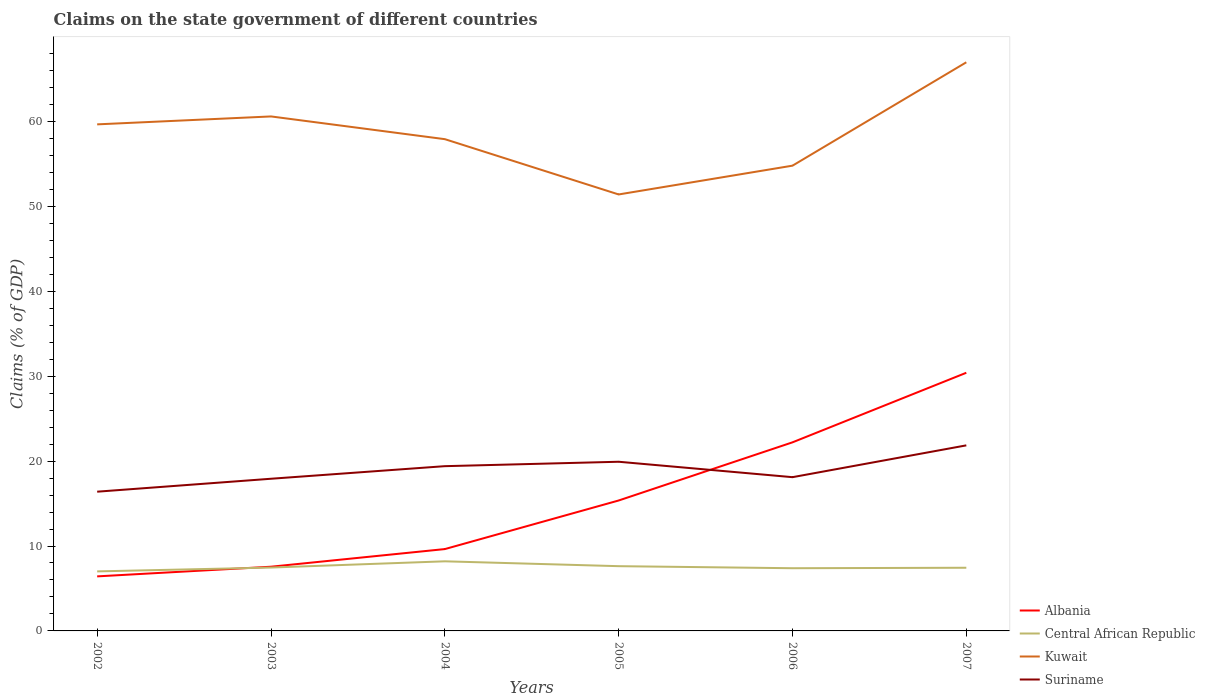Across all years, what is the maximum percentage of GDP claimed on the state government in Kuwait?
Provide a succinct answer. 51.41. In which year was the percentage of GDP claimed on the state government in Suriname maximum?
Your answer should be compact. 2002. What is the total percentage of GDP claimed on the state government in Suriname in the graph?
Keep it short and to the point. -1.93. What is the difference between the highest and the second highest percentage of GDP claimed on the state government in Kuwait?
Your response must be concise. 15.57. Is the percentage of GDP claimed on the state government in Suriname strictly greater than the percentage of GDP claimed on the state government in Central African Republic over the years?
Provide a short and direct response. No. How many years are there in the graph?
Ensure brevity in your answer.  6. What is the difference between two consecutive major ticks on the Y-axis?
Provide a succinct answer. 10. Does the graph contain grids?
Your answer should be very brief. No. Where does the legend appear in the graph?
Keep it short and to the point. Bottom right. What is the title of the graph?
Your answer should be very brief. Claims on the state government of different countries. Does "Bosnia and Herzegovina" appear as one of the legend labels in the graph?
Offer a terse response. No. What is the label or title of the Y-axis?
Your response must be concise. Claims (% of GDP). What is the Claims (% of GDP) in Albania in 2002?
Your response must be concise. 6.42. What is the Claims (% of GDP) of Central African Republic in 2002?
Your answer should be very brief. 7.01. What is the Claims (% of GDP) in Kuwait in 2002?
Your response must be concise. 59.66. What is the Claims (% of GDP) of Suriname in 2002?
Ensure brevity in your answer.  16.4. What is the Claims (% of GDP) in Albania in 2003?
Make the answer very short. 7.56. What is the Claims (% of GDP) in Central African Republic in 2003?
Your response must be concise. 7.46. What is the Claims (% of GDP) of Kuwait in 2003?
Your response must be concise. 60.59. What is the Claims (% of GDP) of Suriname in 2003?
Your answer should be very brief. 17.92. What is the Claims (% of GDP) of Albania in 2004?
Ensure brevity in your answer.  9.64. What is the Claims (% of GDP) in Central African Republic in 2004?
Provide a short and direct response. 8.2. What is the Claims (% of GDP) in Kuwait in 2004?
Ensure brevity in your answer.  57.92. What is the Claims (% of GDP) in Suriname in 2004?
Ensure brevity in your answer.  19.4. What is the Claims (% of GDP) of Albania in 2005?
Your response must be concise. 15.36. What is the Claims (% of GDP) in Central African Republic in 2005?
Your answer should be compact. 7.63. What is the Claims (% of GDP) in Kuwait in 2005?
Keep it short and to the point. 51.41. What is the Claims (% of GDP) in Suriname in 2005?
Your answer should be very brief. 19.92. What is the Claims (% of GDP) in Albania in 2006?
Offer a very short reply. 22.21. What is the Claims (% of GDP) of Central African Republic in 2006?
Offer a terse response. 7.38. What is the Claims (% of GDP) in Kuwait in 2006?
Make the answer very short. 54.8. What is the Claims (% of GDP) in Suriname in 2006?
Make the answer very short. 18.11. What is the Claims (% of GDP) in Albania in 2007?
Offer a very short reply. 30.41. What is the Claims (% of GDP) of Central African Republic in 2007?
Your answer should be compact. 7.44. What is the Claims (% of GDP) in Kuwait in 2007?
Offer a very short reply. 66.97. What is the Claims (% of GDP) in Suriname in 2007?
Offer a terse response. 21.85. Across all years, what is the maximum Claims (% of GDP) in Albania?
Offer a very short reply. 30.41. Across all years, what is the maximum Claims (% of GDP) of Central African Republic?
Offer a terse response. 8.2. Across all years, what is the maximum Claims (% of GDP) in Kuwait?
Keep it short and to the point. 66.97. Across all years, what is the maximum Claims (% of GDP) in Suriname?
Make the answer very short. 21.85. Across all years, what is the minimum Claims (% of GDP) in Albania?
Your answer should be very brief. 6.42. Across all years, what is the minimum Claims (% of GDP) of Central African Republic?
Your response must be concise. 7.01. Across all years, what is the minimum Claims (% of GDP) of Kuwait?
Your answer should be very brief. 51.41. Across all years, what is the minimum Claims (% of GDP) of Suriname?
Your response must be concise. 16.4. What is the total Claims (% of GDP) in Albania in the graph?
Ensure brevity in your answer.  91.6. What is the total Claims (% of GDP) of Central African Republic in the graph?
Your answer should be compact. 45.12. What is the total Claims (% of GDP) in Kuwait in the graph?
Give a very brief answer. 351.34. What is the total Claims (% of GDP) in Suriname in the graph?
Keep it short and to the point. 113.61. What is the difference between the Claims (% of GDP) of Albania in 2002 and that in 2003?
Keep it short and to the point. -1.14. What is the difference between the Claims (% of GDP) of Central African Republic in 2002 and that in 2003?
Keep it short and to the point. -0.45. What is the difference between the Claims (% of GDP) in Kuwait in 2002 and that in 2003?
Give a very brief answer. -0.93. What is the difference between the Claims (% of GDP) in Suriname in 2002 and that in 2003?
Keep it short and to the point. -1.52. What is the difference between the Claims (% of GDP) in Albania in 2002 and that in 2004?
Make the answer very short. -3.21. What is the difference between the Claims (% of GDP) in Central African Republic in 2002 and that in 2004?
Your answer should be very brief. -1.19. What is the difference between the Claims (% of GDP) of Kuwait in 2002 and that in 2004?
Offer a very short reply. 1.74. What is the difference between the Claims (% of GDP) in Suriname in 2002 and that in 2004?
Provide a short and direct response. -3.01. What is the difference between the Claims (% of GDP) of Albania in 2002 and that in 2005?
Your answer should be very brief. -8.94. What is the difference between the Claims (% of GDP) in Central African Republic in 2002 and that in 2005?
Your answer should be compact. -0.62. What is the difference between the Claims (% of GDP) in Kuwait in 2002 and that in 2005?
Offer a terse response. 8.25. What is the difference between the Claims (% of GDP) in Suriname in 2002 and that in 2005?
Your answer should be compact. -3.53. What is the difference between the Claims (% of GDP) in Albania in 2002 and that in 2006?
Give a very brief answer. -15.79. What is the difference between the Claims (% of GDP) in Central African Republic in 2002 and that in 2006?
Offer a terse response. -0.37. What is the difference between the Claims (% of GDP) in Kuwait in 2002 and that in 2006?
Keep it short and to the point. 4.87. What is the difference between the Claims (% of GDP) in Suriname in 2002 and that in 2006?
Make the answer very short. -1.71. What is the difference between the Claims (% of GDP) of Albania in 2002 and that in 2007?
Make the answer very short. -23.98. What is the difference between the Claims (% of GDP) of Central African Republic in 2002 and that in 2007?
Provide a succinct answer. -0.43. What is the difference between the Claims (% of GDP) in Kuwait in 2002 and that in 2007?
Provide a succinct answer. -7.31. What is the difference between the Claims (% of GDP) in Suriname in 2002 and that in 2007?
Your answer should be compact. -5.46. What is the difference between the Claims (% of GDP) in Albania in 2003 and that in 2004?
Your answer should be compact. -2.08. What is the difference between the Claims (% of GDP) of Central African Republic in 2003 and that in 2004?
Provide a short and direct response. -0.73. What is the difference between the Claims (% of GDP) of Kuwait in 2003 and that in 2004?
Keep it short and to the point. 2.68. What is the difference between the Claims (% of GDP) of Suriname in 2003 and that in 2004?
Give a very brief answer. -1.48. What is the difference between the Claims (% of GDP) in Albania in 2003 and that in 2005?
Keep it short and to the point. -7.8. What is the difference between the Claims (% of GDP) in Central African Republic in 2003 and that in 2005?
Offer a terse response. -0.16. What is the difference between the Claims (% of GDP) of Kuwait in 2003 and that in 2005?
Your answer should be very brief. 9.19. What is the difference between the Claims (% of GDP) of Suriname in 2003 and that in 2005?
Offer a very short reply. -2. What is the difference between the Claims (% of GDP) in Albania in 2003 and that in 2006?
Provide a short and direct response. -14.65. What is the difference between the Claims (% of GDP) in Central African Republic in 2003 and that in 2006?
Keep it short and to the point. 0.08. What is the difference between the Claims (% of GDP) in Kuwait in 2003 and that in 2006?
Keep it short and to the point. 5.8. What is the difference between the Claims (% of GDP) of Suriname in 2003 and that in 2006?
Offer a very short reply. -0.19. What is the difference between the Claims (% of GDP) in Albania in 2003 and that in 2007?
Make the answer very short. -22.84. What is the difference between the Claims (% of GDP) of Central African Republic in 2003 and that in 2007?
Ensure brevity in your answer.  0.02. What is the difference between the Claims (% of GDP) in Kuwait in 2003 and that in 2007?
Keep it short and to the point. -6.38. What is the difference between the Claims (% of GDP) of Suriname in 2003 and that in 2007?
Offer a very short reply. -3.93. What is the difference between the Claims (% of GDP) in Albania in 2004 and that in 2005?
Ensure brevity in your answer.  -5.72. What is the difference between the Claims (% of GDP) of Central African Republic in 2004 and that in 2005?
Provide a succinct answer. 0.57. What is the difference between the Claims (% of GDP) in Kuwait in 2004 and that in 2005?
Your answer should be very brief. 6.51. What is the difference between the Claims (% of GDP) in Suriname in 2004 and that in 2005?
Your answer should be compact. -0.52. What is the difference between the Claims (% of GDP) of Albania in 2004 and that in 2006?
Ensure brevity in your answer.  -12.57. What is the difference between the Claims (% of GDP) of Central African Republic in 2004 and that in 2006?
Offer a terse response. 0.81. What is the difference between the Claims (% of GDP) in Kuwait in 2004 and that in 2006?
Your response must be concise. 3.12. What is the difference between the Claims (% of GDP) of Suriname in 2004 and that in 2006?
Offer a terse response. 1.3. What is the difference between the Claims (% of GDP) in Albania in 2004 and that in 2007?
Offer a very short reply. -20.77. What is the difference between the Claims (% of GDP) in Central African Republic in 2004 and that in 2007?
Your response must be concise. 0.76. What is the difference between the Claims (% of GDP) in Kuwait in 2004 and that in 2007?
Give a very brief answer. -9.05. What is the difference between the Claims (% of GDP) in Suriname in 2004 and that in 2007?
Keep it short and to the point. -2.45. What is the difference between the Claims (% of GDP) in Albania in 2005 and that in 2006?
Offer a very short reply. -6.85. What is the difference between the Claims (% of GDP) in Central African Republic in 2005 and that in 2006?
Your response must be concise. 0.24. What is the difference between the Claims (% of GDP) in Kuwait in 2005 and that in 2006?
Give a very brief answer. -3.39. What is the difference between the Claims (% of GDP) of Suriname in 2005 and that in 2006?
Ensure brevity in your answer.  1.82. What is the difference between the Claims (% of GDP) in Albania in 2005 and that in 2007?
Make the answer very short. -15.04. What is the difference between the Claims (% of GDP) of Central African Republic in 2005 and that in 2007?
Your response must be concise. 0.19. What is the difference between the Claims (% of GDP) in Kuwait in 2005 and that in 2007?
Provide a succinct answer. -15.57. What is the difference between the Claims (% of GDP) of Suriname in 2005 and that in 2007?
Make the answer very short. -1.93. What is the difference between the Claims (% of GDP) in Albania in 2006 and that in 2007?
Provide a succinct answer. -8.19. What is the difference between the Claims (% of GDP) in Central African Republic in 2006 and that in 2007?
Your answer should be compact. -0.06. What is the difference between the Claims (% of GDP) in Kuwait in 2006 and that in 2007?
Offer a terse response. -12.18. What is the difference between the Claims (% of GDP) in Suriname in 2006 and that in 2007?
Your answer should be compact. -3.75. What is the difference between the Claims (% of GDP) of Albania in 2002 and the Claims (% of GDP) of Central African Republic in 2003?
Ensure brevity in your answer.  -1.04. What is the difference between the Claims (% of GDP) of Albania in 2002 and the Claims (% of GDP) of Kuwait in 2003?
Offer a very short reply. -54.17. What is the difference between the Claims (% of GDP) of Albania in 2002 and the Claims (% of GDP) of Suriname in 2003?
Give a very brief answer. -11.5. What is the difference between the Claims (% of GDP) of Central African Republic in 2002 and the Claims (% of GDP) of Kuwait in 2003?
Offer a very short reply. -53.58. What is the difference between the Claims (% of GDP) in Central African Republic in 2002 and the Claims (% of GDP) in Suriname in 2003?
Give a very brief answer. -10.91. What is the difference between the Claims (% of GDP) in Kuwait in 2002 and the Claims (% of GDP) in Suriname in 2003?
Offer a terse response. 41.74. What is the difference between the Claims (% of GDP) of Albania in 2002 and the Claims (% of GDP) of Central African Republic in 2004?
Provide a short and direct response. -1.77. What is the difference between the Claims (% of GDP) of Albania in 2002 and the Claims (% of GDP) of Kuwait in 2004?
Give a very brief answer. -51.49. What is the difference between the Claims (% of GDP) in Albania in 2002 and the Claims (% of GDP) in Suriname in 2004?
Ensure brevity in your answer.  -12.98. What is the difference between the Claims (% of GDP) of Central African Republic in 2002 and the Claims (% of GDP) of Kuwait in 2004?
Provide a succinct answer. -50.91. What is the difference between the Claims (% of GDP) in Central African Republic in 2002 and the Claims (% of GDP) in Suriname in 2004?
Offer a terse response. -12.39. What is the difference between the Claims (% of GDP) of Kuwait in 2002 and the Claims (% of GDP) of Suriname in 2004?
Provide a succinct answer. 40.26. What is the difference between the Claims (% of GDP) in Albania in 2002 and the Claims (% of GDP) in Central African Republic in 2005?
Provide a succinct answer. -1.2. What is the difference between the Claims (% of GDP) in Albania in 2002 and the Claims (% of GDP) in Kuwait in 2005?
Provide a short and direct response. -44.98. What is the difference between the Claims (% of GDP) in Albania in 2002 and the Claims (% of GDP) in Suriname in 2005?
Keep it short and to the point. -13.5. What is the difference between the Claims (% of GDP) in Central African Republic in 2002 and the Claims (% of GDP) in Kuwait in 2005?
Make the answer very short. -44.4. What is the difference between the Claims (% of GDP) of Central African Republic in 2002 and the Claims (% of GDP) of Suriname in 2005?
Provide a succinct answer. -12.91. What is the difference between the Claims (% of GDP) of Kuwait in 2002 and the Claims (% of GDP) of Suriname in 2005?
Your answer should be very brief. 39.74. What is the difference between the Claims (% of GDP) in Albania in 2002 and the Claims (% of GDP) in Central African Republic in 2006?
Give a very brief answer. -0.96. What is the difference between the Claims (% of GDP) of Albania in 2002 and the Claims (% of GDP) of Kuwait in 2006?
Your answer should be compact. -48.37. What is the difference between the Claims (% of GDP) in Albania in 2002 and the Claims (% of GDP) in Suriname in 2006?
Your answer should be very brief. -11.68. What is the difference between the Claims (% of GDP) of Central African Republic in 2002 and the Claims (% of GDP) of Kuwait in 2006?
Provide a short and direct response. -47.78. What is the difference between the Claims (% of GDP) of Central African Republic in 2002 and the Claims (% of GDP) of Suriname in 2006?
Make the answer very short. -11.1. What is the difference between the Claims (% of GDP) of Kuwait in 2002 and the Claims (% of GDP) of Suriname in 2006?
Make the answer very short. 41.55. What is the difference between the Claims (% of GDP) of Albania in 2002 and the Claims (% of GDP) of Central African Republic in 2007?
Make the answer very short. -1.02. What is the difference between the Claims (% of GDP) of Albania in 2002 and the Claims (% of GDP) of Kuwait in 2007?
Your answer should be very brief. -60.55. What is the difference between the Claims (% of GDP) in Albania in 2002 and the Claims (% of GDP) in Suriname in 2007?
Offer a very short reply. -15.43. What is the difference between the Claims (% of GDP) in Central African Republic in 2002 and the Claims (% of GDP) in Kuwait in 2007?
Offer a very short reply. -59.96. What is the difference between the Claims (% of GDP) of Central African Republic in 2002 and the Claims (% of GDP) of Suriname in 2007?
Your answer should be very brief. -14.84. What is the difference between the Claims (% of GDP) of Kuwait in 2002 and the Claims (% of GDP) of Suriname in 2007?
Offer a very short reply. 37.81. What is the difference between the Claims (% of GDP) of Albania in 2003 and the Claims (% of GDP) of Central African Republic in 2004?
Make the answer very short. -0.64. What is the difference between the Claims (% of GDP) of Albania in 2003 and the Claims (% of GDP) of Kuwait in 2004?
Provide a succinct answer. -50.36. What is the difference between the Claims (% of GDP) in Albania in 2003 and the Claims (% of GDP) in Suriname in 2004?
Your answer should be very brief. -11.84. What is the difference between the Claims (% of GDP) in Central African Republic in 2003 and the Claims (% of GDP) in Kuwait in 2004?
Ensure brevity in your answer.  -50.45. What is the difference between the Claims (% of GDP) of Central African Republic in 2003 and the Claims (% of GDP) of Suriname in 2004?
Your answer should be compact. -11.94. What is the difference between the Claims (% of GDP) in Kuwait in 2003 and the Claims (% of GDP) in Suriname in 2004?
Make the answer very short. 41.19. What is the difference between the Claims (% of GDP) of Albania in 2003 and the Claims (% of GDP) of Central African Republic in 2005?
Ensure brevity in your answer.  -0.06. What is the difference between the Claims (% of GDP) in Albania in 2003 and the Claims (% of GDP) in Kuwait in 2005?
Ensure brevity in your answer.  -43.84. What is the difference between the Claims (% of GDP) in Albania in 2003 and the Claims (% of GDP) in Suriname in 2005?
Your response must be concise. -12.36. What is the difference between the Claims (% of GDP) in Central African Republic in 2003 and the Claims (% of GDP) in Kuwait in 2005?
Offer a terse response. -43.94. What is the difference between the Claims (% of GDP) of Central African Republic in 2003 and the Claims (% of GDP) of Suriname in 2005?
Provide a succinct answer. -12.46. What is the difference between the Claims (% of GDP) of Kuwait in 2003 and the Claims (% of GDP) of Suriname in 2005?
Give a very brief answer. 40.67. What is the difference between the Claims (% of GDP) in Albania in 2003 and the Claims (% of GDP) in Central African Republic in 2006?
Provide a succinct answer. 0.18. What is the difference between the Claims (% of GDP) in Albania in 2003 and the Claims (% of GDP) in Kuwait in 2006?
Your answer should be compact. -47.23. What is the difference between the Claims (% of GDP) in Albania in 2003 and the Claims (% of GDP) in Suriname in 2006?
Give a very brief answer. -10.55. What is the difference between the Claims (% of GDP) of Central African Republic in 2003 and the Claims (% of GDP) of Kuwait in 2006?
Offer a very short reply. -47.33. What is the difference between the Claims (% of GDP) of Central African Republic in 2003 and the Claims (% of GDP) of Suriname in 2006?
Your answer should be very brief. -10.64. What is the difference between the Claims (% of GDP) of Kuwait in 2003 and the Claims (% of GDP) of Suriname in 2006?
Your response must be concise. 42.49. What is the difference between the Claims (% of GDP) in Albania in 2003 and the Claims (% of GDP) in Central African Republic in 2007?
Your response must be concise. 0.12. What is the difference between the Claims (% of GDP) in Albania in 2003 and the Claims (% of GDP) in Kuwait in 2007?
Make the answer very short. -59.41. What is the difference between the Claims (% of GDP) in Albania in 2003 and the Claims (% of GDP) in Suriname in 2007?
Your answer should be very brief. -14.29. What is the difference between the Claims (% of GDP) in Central African Republic in 2003 and the Claims (% of GDP) in Kuwait in 2007?
Provide a succinct answer. -59.51. What is the difference between the Claims (% of GDP) of Central African Republic in 2003 and the Claims (% of GDP) of Suriname in 2007?
Ensure brevity in your answer.  -14.39. What is the difference between the Claims (% of GDP) in Kuwait in 2003 and the Claims (% of GDP) in Suriname in 2007?
Offer a terse response. 38.74. What is the difference between the Claims (% of GDP) in Albania in 2004 and the Claims (% of GDP) in Central African Republic in 2005?
Keep it short and to the point. 2.01. What is the difference between the Claims (% of GDP) in Albania in 2004 and the Claims (% of GDP) in Kuwait in 2005?
Ensure brevity in your answer.  -41.77. What is the difference between the Claims (% of GDP) in Albania in 2004 and the Claims (% of GDP) in Suriname in 2005?
Your answer should be compact. -10.29. What is the difference between the Claims (% of GDP) in Central African Republic in 2004 and the Claims (% of GDP) in Kuwait in 2005?
Provide a succinct answer. -43.21. What is the difference between the Claims (% of GDP) of Central African Republic in 2004 and the Claims (% of GDP) of Suriname in 2005?
Provide a short and direct response. -11.73. What is the difference between the Claims (% of GDP) of Kuwait in 2004 and the Claims (% of GDP) of Suriname in 2005?
Make the answer very short. 37.99. What is the difference between the Claims (% of GDP) of Albania in 2004 and the Claims (% of GDP) of Central African Republic in 2006?
Your response must be concise. 2.25. What is the difference between the Claims (% of GDP) in Albania in 2004 and the Claims (% of GDP) in Kuwait in 2006?
Your answer should be very brief. -45.16. What is the difference between the Claims (% of GDP) of Albania in 2004 and the Claims (% of GDP) of Suriname in 2006?
Your answer should be very brief. -8.47. What is the difference between the Claims (% of GDP) of Central African Republic in 2004 and the Claims (% of GDP) of Kuwait in 2006?
Offer a terse response. -46.6. What is the difference between the Claims (% of GDP) in Central African Republic in 2004 and the Claims (% of GDP) in Suriname in 2006?
Offer a very short reply. -9.91. What is the difference between the Claims (% of GDP) of Kuwait in 2004 and the Claims (% of GDP) of Suriname in 2006?
Keep it short and to the point. 39.81. What is the difference between the Claims (% of GDP) of Albania in 2004 and the Claims (% of GDP) of Central African Republic in 2007?
Your answer should be compact. 2.2. What is the difference between the Claims (% of GDP) in Albania in 2004 and the Claims (% of GDP) in Kuwait in 2007?
Keep it short and to the point. -57.33. What is the difference between the Claims (% of GDP) of Albania in 2004 and the Claims (% of GDP) of Suriname in 2007?
Provide a short and direct response. -12.22. What is the difference between the Claims (% of GDP) in Central African Republic in 2004 and the Claims (% of GDP) in Kuwait in 2007?
Ensure brevity in your answer.  -58.77. What is the difference between the Claims (% of GDP) of Central African Republic in 2004 and the Claims (% of GDP) of Suriname in 2007?
Your answer should be compact. -13.66. What is the difference between the Claims (% of GDP) in Kuwait in 2004 and the Claims (% of GDP) in Suriname in 2007?
Offer a very short reply. 36.06. What is the difference between the Claims (% of GDP) in Albania in 2005 and the Claims (% of GDP) in Central African Republic in 2006?
Give a very brief answer. 7.98. What is the difference between the Claims (% of GDP) in Albania in 2005 and the Claims (% of GDP) in Kuwait in 2006?
Your response must be concise. -39.43. What is the difference between the Claims (% of GDP) in Albania in 2005 and the Claims (% of GDP) in Suriname in 2006?
Make the answer very short. -2.75. What is the difference between the Claims (% of GDP) of Central African Republic in 2005 and the Claims (% of GDP) of Kuwait in 2006?
Your answer should be compact. -47.17. What is the difference between the Claims (% of GDP) of Central African Republic in 2005 and the Claims (% of GDP) of Suriname in 2006?
Your response must be concise. -10.48. What is the difference between the Claims (% of GDP) in Kuwait in 2005 and the Claims (% of GDP) in Suriname in 2006?
Offer a terse response. 33.3. What is the difference between the Claims (% of GDP) of Albania in 2005 and the Claims (% of GDP) of Central African Republic in 2007?
Offer a very short reply. 7.92. What is the difference between the Claims (% of GDP) in Albania in 2005 and the Claims (% of GDP) in Kuwait in 2007?
Offer a very short reply. -51.61. What is the difference between the Claims (% of GDP) in Albania in 2005 and the Claims (% of GDP) in Suriname in 2007?
Make the answer very short. -6.49. What is the difference between the Claims (% of GDP) in Central African Republic in 2005 and the Claims (% of GDP) in Kuwait in 2007?
Keep it short and to the point. -59.35. What is the difference between the Claims (% of GDP) in Central African Republic in 2005 and the Claims (% of GDP) in Suriname in 2007?
Provide a succinct answer. -14.23. What is the difference between the Claims (% of GDP) in Kuwait in 2005 and the Claims (% of GDP) in Suriname in 2007?
Offer a very short reply. 29.55. What is the difference between the Claims (% of GDP) of Albania in 2006 and the Claims (% of GDP) of Central African Republic in 2007?
Offer a very short reply. 14.77. What is the difference between the Claims (% of GDP) of Albania in 2006 and the Claims (% of GDP) of Kuwait in 2007?
Keep it short and to the point. -44.76. What is the difference between the Claims (% of GDP) in Albania in 2006 and the Claims (% of GDP) in Suriname in 2007?
Give a very brief answer. 0.36. What is the difference between the Claims (% of GDP) of Central African Republic in 2006 and the Claims (% of GDP) of Kuwait in 2007?
Make the answer very short. -59.59. What is the difference between the Claims (% of GDP) of Central African Republic in 2006 and the Claims (% of GDP) of Suriname in 2007?
Offer a terse response. -14.47. What is the difference between the Claims (% of GDP) in Kuwait in 2006 and the Claims (% of GDP) in Suriname in 2007?
Offer a terse response. 32.94. What is the average Claims (% of GDP) of Albania per year?
Offer a terse response. 15.27. What is the average Claims (% of GDP) of Central African Republic per year?
Provide a succinct answer. 7.52. What is the average Claims (% of GDP) of Kuwait per year?
Your answer should be compact. 58.56. What is the average Claims (% of GDP) in Suriname per year?
Your answer should be very brief. 18.93. In the year 2002, what is the difference between the Claims (% of GDP) of Albania and Claims (% of GDP) of Central African Republic?
Your response must be concise. -0.59. In the year 2002, what is the difference between the Claims (% of GDP) in Albania and Claims (% of GDP) in Kuwait?
Give a very brief answer. -53.24. In the year 2002, what is the difference between the Claims (% of GDP) of Albania and Claims (% of GDP) of Suriname?
Keep it short and to the point. -9.97. In the year 2002, what is the difference between the Claims (% of GDP) in Central African Republic and Claims (% of GDP) in Kuwait?
Make the answer very short. -52.65. In the year 2002, what is the difference between the Claims (% of GDP) of Central African Republic and Claims (% of GDP) of Suriname?
Your answer should be compact. -9.39. In the year 2002, what is the difference between the Claims (% of GDP) of Kuwait and Claims (% of GDP) of Suriname?
Your response must be concise. 43.26. In the year 2003, what is the difference between the Claims (% of GDP) of Albania and Claims (% of GDP) of Central African Republic?
Offer a terse response. 0.1. In the year 2003, what is the difference between the Claims (% of GDP) in Albania and Claims (% of GDP) in Kuwait?
Ensure brevity in your answer.  -53.03. In the year 2003, what is the difference between the Claims (% of GDP) in Albania and Claims (% of GDP) in Suriname?
Provide a succinct answer. -10.36. In the year 2003, what is the difference between the Claims (% of GDP) in Central African Republic and Claims (% of GDP) in Kuwait?
Your response must be concise. -53.13. In the year 2003, what is the difference between the Claims (% of GDP) in Central African Republic and Claims (% of GDP) in Suriname?
Ensure brevity in your answer.  -10.46. In the year 2003, what is the difference between the Claims (% of GDP) of Kuwait and Claims (% of GDP) of Suriname?
Keep it short and to the point. 42.67. In the year 2004, what is the difference between the Claims (% of GDP) of Albania and Claims (% of GDP) of Central African Republic?
Offer a terse response. 1.44. In the year 2004, what is the difference between the Claims (% of GDP) in Albania and Claims (% of GDP) in Kuwait?
Your answer should be compact. -48.28. In the year 2004, what is the difference between the Claims (% of GDP) in Albania and Claims (% of GDP) in Suriname?
Your answer should be compact. -9.77. In the year 2004, what is the difference between the Claims (% of GDP) of Central African Republic and Claims (% of GDP) of Kuwait?
Your response must be concise. -49.72. In the year 2004, what is the difference between the Claims (% of GDP) in Central African Republic and Claims (% of GDP) in Suriname?
Offer a terse response. -11.21. In the year 2004, what is the difference between the Claims (% of GDP) of Kuwait and Claims (% of GDP) of Suriname?
Provide a short and direct response. 38.51. In the year 2005, what is the difference between the Claims (% of GDP) in Albania and Claims (% of GDP) in Central African Republic?
Make the answer very short. 7.74. In the year 2005, what is the difference between the Claims (% of GDP) of Albania and Claims (% of GDP) of Kuwait?
Your response must be concise. -36.04. In the year 2005, what is the difference between the Claims (% of GDP) in Albania and Claims (% of GDP) in Suriname?
Offer a very short reply. -4.56. In the year 2005, what is the difference between the Claims (% of GDP) in Central African Republic and Claims (% of GDP) in Kuwait?
Your answer should be very brief. -43.78. In the year 2005, what is the difference between the Claims (% of GDP) of Central African Republic and Claims (% of GDP) of Suriname?
Make the answer very short. -12.3. In the year 2005, what is the difference between the Claims (% of GDP) in Kuwait and Claims (% of GDP) in Suriname?
Your answer should be compact. 31.48. In the year 2006, what is the difference between the Claims (% of GDP) in Albania and Claims (% of GDP) in Central African Republic?
Give a very brief answer. 14.83. In the year 2006, what is the difference between the Claims (% of GDP) in Albania and Claims (% of GDP) in Kuwait?
Your answer should be very brief. -32.58. In the year 2006, what is the difference between the Claims (% of GDP) of Albania and Claims (% of GDP) of Suriname?
Provide a short and direct response. 4.1. In the year 2006, what is the difference between the Claims (% of GDP) of Central African Republic and Claims (% of GDP) of Kuwait?
Ensure brevity in your answer.  -47.41. In the year 2006, what is the difference between the Claims (% of GDP) of Central African Republic and Claims (% of GDP) of Suriname?
Offer a very short reply. -10.72. In the year 2006, what is the difference between the Claims (% of GDP) of Kuwait and Claims (% of GDP) of Suriname?
Ensure brevity in your answer.  36.69. In the year 2007, what is the difference between the Claims (% of GDP) of Albania and Claims (% of GDP) of Central African Republic?
Provide a succinct answer. 22.97. In the year 2007, what is the difference between the Claims (% of GDP) in Albania and Claims (% of GDP) in Kuwait?
Provide a succinct answer. -36.57. In the year 2007, what is the difference between the Claims (% of GDP) of Albania and Claims (% of GDP) of Suriname?
Offer a very short reply. 8.55. In the year 2007, what is the difference between the Claims (% of GDP) in Central African Republic and Claims (% of GDP) in Kuwait?
Keep it short and to the point. -59.53. In the year 2007, what is the difference between the Claims (% of GDP) in Central African Republic and Claims (% of GDP) in Suriname?
Your response must be concise. -14.41. In the year 2007, what is the difference between the Claims (% of GDP) of Kuwait and Claims (% of GDP) of Suriname?
Offer a very short reply. 45.12. What is the ratio of the Claims (% of GDP) of Albania in 2002 to that in 2003?
Make the answer very short. 0.85. What is the ratio of the Claims (% of GDP) in Central African Republic in 2002 to that in 2003?
Your answer should be compact. 0.94. What is the ratio of the Claims (% of GDP) of Kuwait in 2002 to that in 2003?
Provide a short and direct response. 0.98. What is the ratio of the Claims (% of GDP) of Suriname in 2002 to that in 2003?
Your answer should be compact. 0.91. What is the ratio of the Claims (% of GDP) in Albania in 2002 to that in 2004?
Your answer should be very brief. 0.67. What is the ratio of the Claims (% of GDP) in Central African Republic in 2002 to that in 2004?
Offer a very short reply. 0.86. What is the ratio of the Claims (% of GDP) in Kuwait in 2002 to that in 2004?
Your answer should be compact. 1.03. What is the ratio of the Claims (% of GDP) of Suriname in 2002 to that in 2004?
Offer a very short reply. 0.85. What is the ratio of the Claims (% of GDP) in Albania in 2002 to that in 2005?
Ensure brevity in your answer.  0.42. What is the ratio of the Claims (% of GDP) of Central African Republic in 2002 to that in 2005?
Offer a terse response. 0.92. What is the ratio of the Claims (% of GDP) in Kuwait in 2002 to that in 2005?
Offer a terse response. 1.16. What is the ratio of the Claims (% of GDP) in Suriname in 2002 to that in 2005?
Make the answer very short. 0.82. What is the ratio of the Claims (% of GDP) of Albania in 2002 to that in 2006?
Make the answer very short. 0.29. What is the ratio of the Claims (% of GDP) of Central African Republic in 2002 to that in 2006?
Ensure brevity in your answer.  0.95. What is the ratio of the Claims (% of GDP) in Kuwait in 2002 to that in 2006?
Provide a short and direct response. 1.09. What is the ratio of the Claims (% of GDP) of Suriname in 2002 to that in 2006?
Offer a very short reply. 0.91. What is the ratio of the Claims (% of GDP) in Albania in 2002 to that in 2007?
Provide a short and direct response. 0.21. What is the ratio of the Claims (% of GDP) in Central African Republic in 2002 to that in 2007?
Provide a succinct answer. 0.94. What is the ratio of the Claims (% of GDP) in Kuwait in 2002 to that in 2007?
Your answer should be compact. 0.89. What is the ratio of the Claims (% of GDP) of Suriname in 2002 to that in 2007?
Offer a very short reply. 0.75. What is the ratio of the Claims (% of GDP) of Albania in 2003 to that in 2004?
Provide a succinct answer. 0.78. What is the ratio of the Claims (% of GDP) in Central African Republic in 2003 to that in 2004?
Ensure brevity in your answer.  0.91. What is the ratio of the Claims (% of GDP) of Kuwait in 2003 to that in 2004?
Give a very brief answer. 1.05. What is the ratio of the Claims (% of GDP) in Suriname in 2003 to that in 2004?
Ensure brevity in your answer.  0.92. What is the ratio of the Claims (% of GDP) in Albania in 2003 to that in 2005?
Ensure brevity in your answer.  0.49. What is the ratio of the Claims (% of GDP) in Central African Republic in 2003 to that in 2005?
Offer a terse response. 0.98. What is the ratio of the Claims (% of GDP) of Kuwait in 2003 to that in 2005?
Your answer should be compact. 1.18. What is the ratio of the Claims (% of GDP) of Suriname in 2003 to that in 2005?
Your response must be concise. 0.9. What is the ratio of the Claims (% of GDP) of Albania in 2003 to that in 2006?
Your answer should be compact. 0.34. What is the ratio of the Claims (% of GDP) in Central African Republic in 2003 to that in 2006?
Your answer should be very brief. 1.01. What is the ratio of the Claims (% of GDP) of Kuwait in 2003 to that in 2006?
Your answer should be compact. 1.11. What is the ratio of the Claims (% of GDP) in Albania in 2003 to that in 2007?
Make the answer very short. 0.25. What is the ratio of the Claims (% of GDP) of Central African Republic in 2003 to that in 2007?
Offer a very short reply. 1. What is the ratio of the Claims (% of GDP) of Kuwait in 2003 to that in 2007?
Ensure brevity in your answer.  0.9. What is the ratio of the Claims (% of GDP) in Suriname in 2003 to that in 2007?
Provide a succinct answer. 0.82. What is the ratio of the Claims (% of GDP) in Albania in 2004 to that in 2005?
Provide a short and direct response. 0.63. What is the ratio of the Claims (% of GDP) in Central African Republic in 2004 to that in 2005?
Provide a short and direct response. 1.08. What is the ratio of the Claims (% of GDP) of Kuwait in 2004 to that in 2005?
Make the answer very short. 1.13. What is the ratio of the Claims (% of GDP) of Suriname in 2004 to that in 2005?
Provide a short and direct response. 0.97. What is the ratio of the Claims (% of GDP) in Albania in 2004 to that in 2006?
Make the answer very short. 0.43. What is the ratio of the Claims (% of GDP) of Central African Republic in 2004 to that in 2006?
Your answer should be very brief. 1.11. What is the ratio of the Claims (% of GDP) of Kuwait in 2004 to that in 2006?
Your answer should be compact. 1.06. What is the ratio of the Claims (% of GDP) of Suriname in 2004 to that in 2006?
Your answer should be compact. 1.07. What is the ratio of the Claims (% of GDP) of Albania in 2004 to that in 2007?
Offer a very short reply. 0.32. What is the ratio of the Claims (% of GDP) of Central African Republic in 2004 to that in 2007?
Your answer should be very brief. 1.1. What is the ratio of the Claims (% of GDP) in Kuwait in 2004 to that in 2007?
Provide a succinct answer. 0.86. What is the ratio of the Claims (% of GDP) in Suriname in 2004 to that in 2007?
Give a very brief answer. 0.89. What is the ratio of the Claims (% of GDP) of Albania in 2005 to that in 2006?
Offer a very short reply. 0.69. What is the ratio of the Claims (% of GDP) in Central African Republic in 2005 to that in 2006?
Make the answer very short. 1.03. What is the ratio of the Claims (% of GDP) in Kuwait in 2005 to that in 2006?
Ensure brevity in your answer.  0.94. What is the ratio of the Claims (% of GDP) in Suriname in 2005 to that in 2006?
Keep it short and to the point. 1.1. What is the ratio of the Claims (% of GDP) of Albania in 2005 to that in 2007?
Your response must be concise. 0.51. What is the ratio of the Claims (% of GDP) of Kuwait in 2005 to that in 2007?
Keep it short and to the point. 0.77. What is the ratio of the Claims (% of GDP) of Suriname in 2005 to that in 2007?
Offer a very short reply. 0.91. What is the ratio of the Claims (% of GDP) of Albania in 2006 to that in 2007?
Your answer should be compact. 0.73. What is the ratio of the Claims (% of GDP) of Central African Republic in 2006 to that in 2007?
Offer a very short reply. 0.99. What is the ratio of the Claims (% of GDP) in Kuwait in 2006 to that in 2007?
Give a very brief answer. 0.82. What is the ratio of the Claims (% of GDP) of Suriname in 2006 to that in 2007?
Provide a succinct answer. 0.83. What is the difference between the highest and the second highest Claims (% of GDP) of Albania?
Provide a short and direct response. 8.19. What is the difference between the highest and the second highest Claims (% of GDP) in Central African Republic?
Keep it short and to the point. 0.57. What is the difference between the highest and the second highest Claims (% of GDP) of Kuwait?
Offer a very short reply. 6.38. What is the difference between the highest and the second highest Claims (% of GDP) of Suriname?
Offer a very short reply. 1.93. What is the difference between the highest and the lowest Claims (% of GDP) in Albania?
Give a very brief answer. 23.98. What is the difference between the highest and the lowest Claims (% of GDP) of Central African Republic?
Offer a terse response. 1.19. What is the difference between the highest and the lowest Claims (% of GDP) in Kuwait?
Make the answer very short. 15.57. What is the difference between the highest and the lowest Claims (% of GDP) of Suriname?
Ensure brevity in your answer.  5.46. 